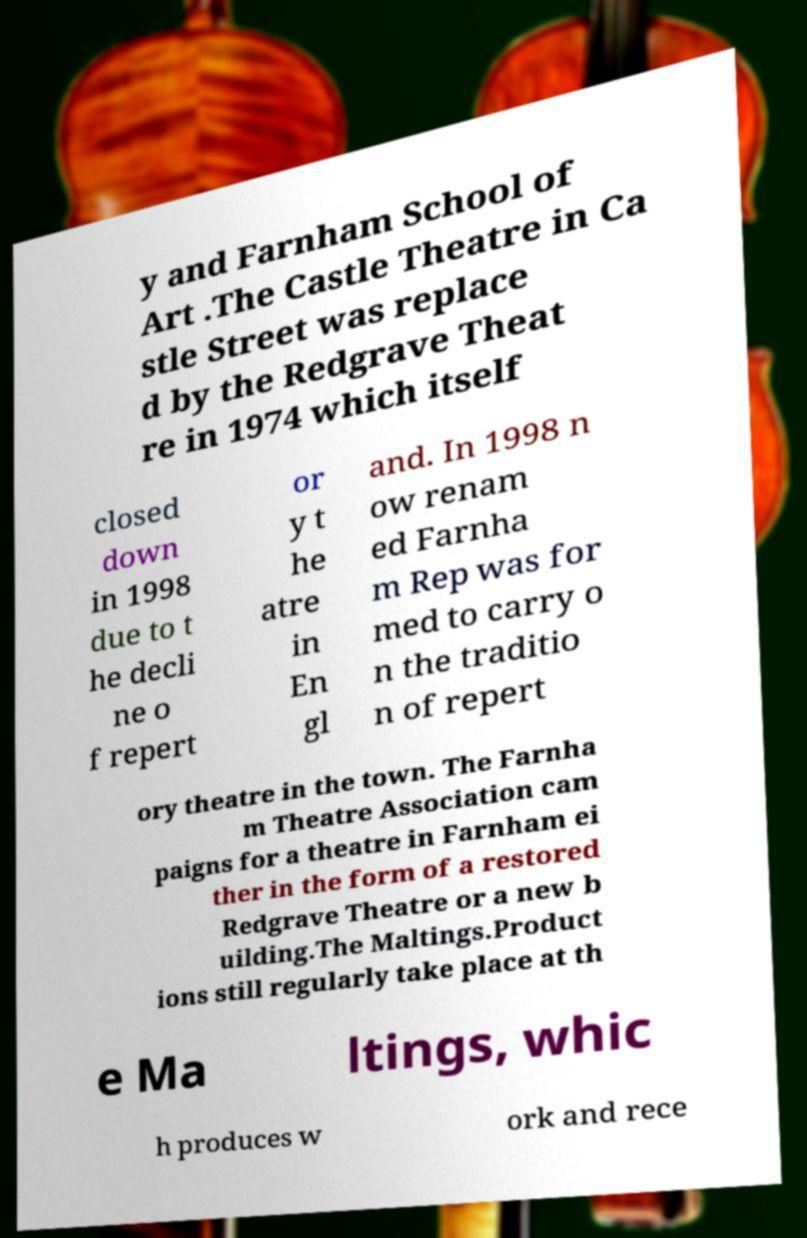Could you extract and type out the text from this image? y and Farnham School of Art .The Castle Theatre in Ca stle Street was replace d by the Redgrave Theat re in 1974 which itself closed down in 1998 due to t he decli ne o f repert or y t he atre in En gl and. In 1998 n ow renam ed Farnha m Rep was for med to carry o n the traditio n of repert ory theatre in the town. The Farnha m Theatre Association cam paigns for a theatre in Farnham ei ther in the form of a restored Redgrave Theatre or a new b uilding.The Maltings.Product ions still regularly take place at th e Ma ltings, whic h produces w ork and rece 